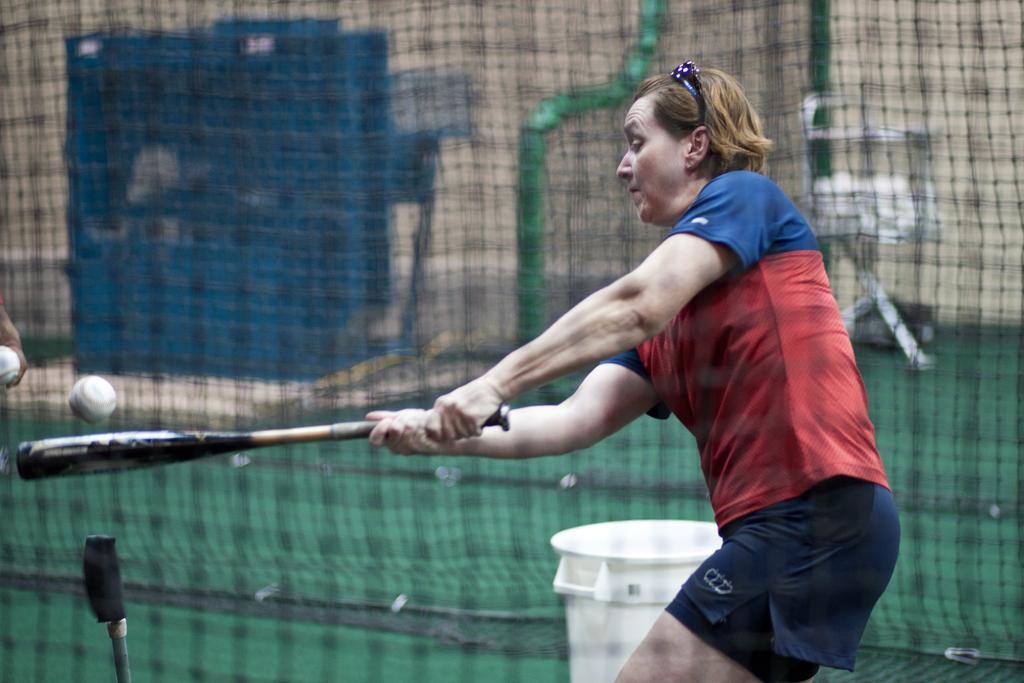Describe this image in one or two sentences. In this image, I can see a woman standing and holding a baseball bat. In the background, I can see sports net, a bucket and few other objects. On the left side of the image, I can see two baseballs. 